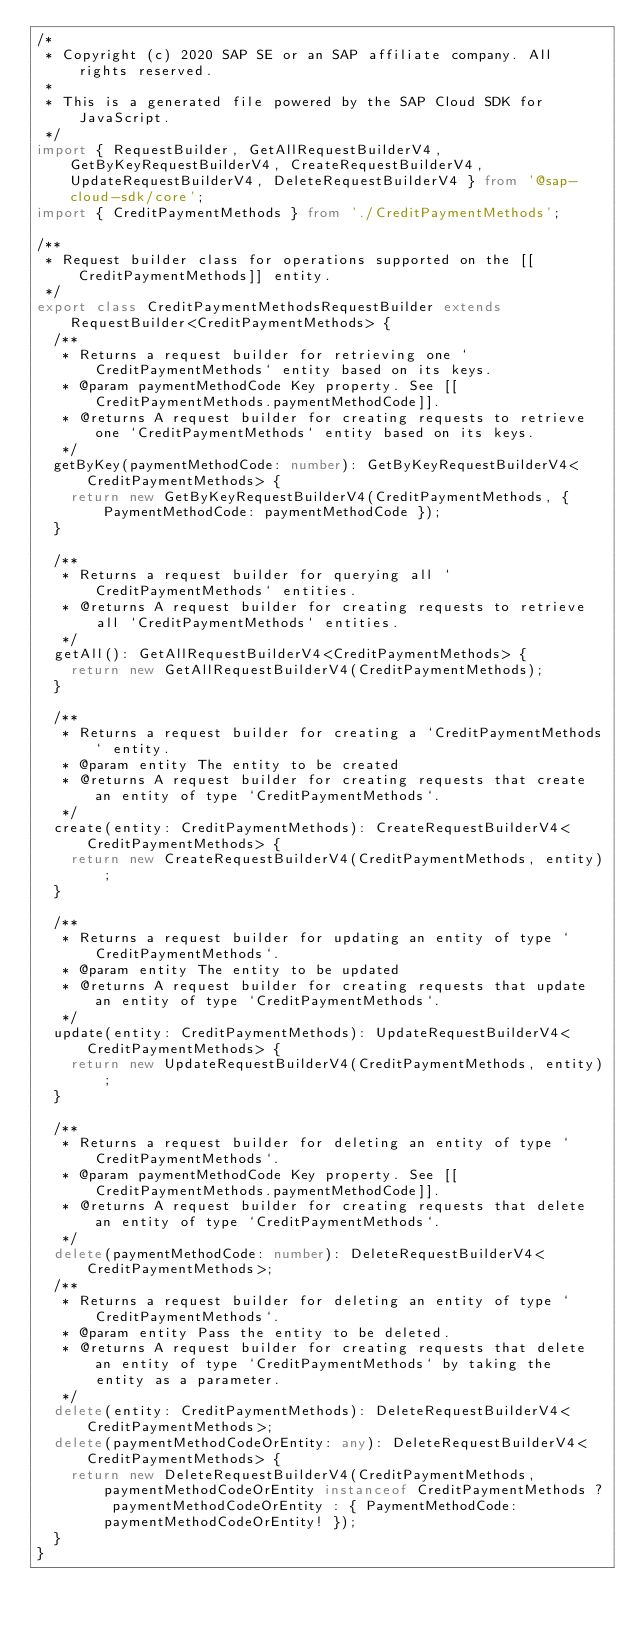<code> <loc_0><loc_0><loc_500><loc_500><_TypeScript_>/*
 * Copyright (c) 2020 SAP SE or an SAP affiliate company. All rights reserved.
 *
 * This is a generated file powered by the SAP Cloud SDK for JavaScript.
 */
import { RequestBuilder, GetAllRequestBuilderV4, GetByKeyRequestBuilderV4, CreateRequestBuilderV4, UpdateRequestBuilderV4, DeleteRequestBuilderV4 } from '@sap-cloud-sdk/core';
import { CreditPaymentMethods } from './CreditPaymentMethods';

/**
 * Request builder class for operations supported on the [[CreditPaymentMethods]] entity.
 */
export class CreditPaymentMethodsRequestBuilder extends RequestBuilder<CreditPaymentMethods> {
  /**
   * Returns a request builder for retrieving one `CreditPaymentMethods` entity based on its keys.
   * @param paymentMethodCode Key property. See [[CreditPaymentMethods.paymentMethodCode]].
   * @returns A request builder for creating requests to retrieve one `CreditPaymentMethods` entity based on its keys.
   */
  getByKey(paymentMethodCode: number): GetByKeyRequestBuilderV4<CreditPaymentMethods> {
    return new GetByKeyRequestBuilderV4(CreditPaymentMethods, { PaymentMethodCode: paymentMethodCode });
  }

  /**
   * Returns a request builder for querying all `CreditPaymentMethods` entities.
   * @returns A request builder for creating requests to retrieve all `CreditPaymentMethods` entities.
   */
  getAll(): GetAllRequestBuilderV4<CreditPaymentMethods> {
    return new GetAllRequestBuilderV4(CreditPaymentMethods);
  }

  /**
   * Returns a request builder for creating a `CreditPaymentMethods` entity.
   * @param entity The entity to be created
   * @returns A request builder for creating requests that create an entity of type `CreditPaymentMethods`.
   */
  create(entity: CreditPaymentMethods): CreateRequestBuilderV4<CreditPaymentMethods> {
    return new CreateRequestBuilderV4(CreditPaymentMethods, entity);
  }

  /**
   * Returns a request builder for updating an entity of type `CreditPaymentMethods`.
   * @param entity The entity to be updated
   * @returns A request builder for creating requests that update an entity of type `CreditPaymentMethods`.
   */
  update(entity: CreditPaymentMethods): UpdateRequestBuilderV4<CreditPaymentMethods> {
    return new UpdateRequestBuilderV4(CreditPaymentMethods, entity);
  }

  /**
   * Returns a request builder for deleting an entity of type `CreditPaymentMethods`.
   * @param paymentMethodCode Key property. See [[CreditPaymentMethods.paymentMethodCode]].
   * @returns A request builder for creating requests that delete an entity of type `CreditPaymentMethods`.
   */
  delete(paymentMethodCode: number): DeleteRequestBuilderV4<CreditPaymentMethods>;
  /**
   * Returns a request builder for deleting an entity of type `CreditPaymentMethods`.
   * @param entity Pass the entity to be deleted.
   * @returns A request builder for creating requests that delete an entity of type `CreditPaymentMethods` by taking the entity as a parameter.
   */
  delete(entity: CreditPaymentMethods): DeleteRequestBuilderV4<CreditPaymentMethods>;
  delete(paymentMethodCodeOrEntity: any): DeleteRequestBuilderV4<CreditPaymentMethods> {
    return new DeleteRequestBuilderV4(CreditPaymentMethods, paymentMethodCodeOrEntity instanceof CreditPaymentMethods ? paymentMethodCodeOrEntity : { PaymentMethodCode: paymentMethodCodeOrEntity! });
  }
}
</code> 